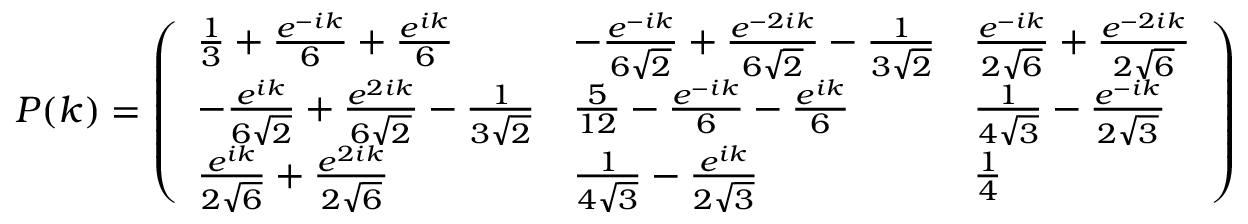Convert formula to latex. <formula><loc_0><loc_0><loc_500><loc_500>\begin{array} { r } { P ( k ) = \left ( \begin{array} { l l l } { \frac { 1 } { 3 } + \frac { e ^ { - i k } } { 6 } + \frac { e ^ { i k } } { 6 } } & { - \frac { e ^ { - i k } } { 6 \sqrt { 2 } } + \frac { e ^ { - 2 i k } } { 6 \sqrt { 2 } } - \frac { 1 } { 3 \sqrt { 2 } } } & { \frac { e ^ { - i k } } { 2 \sqrt { 6 } } + \frac { e ^ { - 2 i k } } { 2 \sqrt { 6 } } } \\ { - \frac { e ^ { i k } } { 6 \sqrt { 2 } } + \frac { e ^ { 2 i k } } { 6 \sqrt { 2 } } - \frac { 1 } { 3 \sqrt { 2 } } } & { \frac { 5 } { 1 2 } - \frac { e ^ { - i k } } { 6 } - \frac { e ^ { i k } } { 6 } } & { \frac { 1 } { 4 \sqrt { 3 } } - \frac { e ^ { - i k } } { 2 \sqrt { 3 } } } \\ { \frac { e ^ { i k } } { 2 \sqrt { 6 } } + \frac { e ^ { 2 i k } } { 2 \sqrt { 6 } } } & { \frac { 1 } { 4 \sqrt { 3 } } - \frac { e ^ { i k } } { 2 \sqrt { 3 } } } & { \frac { 1 } { 4 } } \end{array} \right ) } \end{array}</formula> 